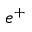Convert formula to latex. <formula><loc_0><loc_0><loc_500><loc_500>e ^ { + }</formula> 